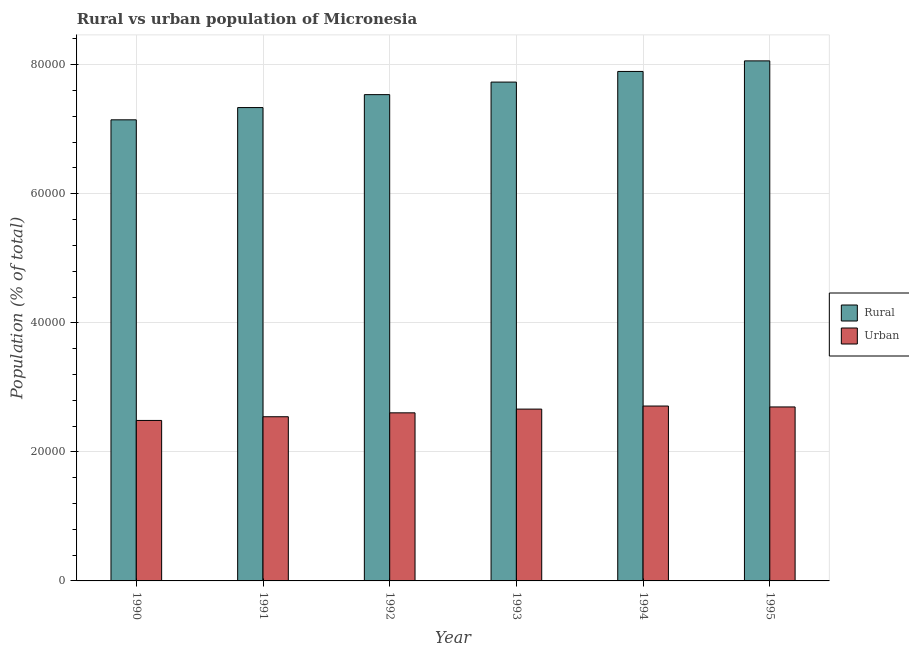How many different coloured bars are there?
Offer a very short reply. 2. Are the number of bars on each tick of the X-axis equal?
Provide a succinct answer. Yes. How many bars are there on the 2nd tick from the right?
Keep it short and to the point. 2. In how many cases, is the number of bars for a given year not equal to the number of legend labels?
Your answer should be compact. 0. What is the rural population density in 1993?
Your answer should be very brief. 7.73e+04. Across all years, what is the maximum urban population density?
Keep it short and to the point. 2.71e+04. Across all years, what is the minimum rural population density?
Ensure brevity in your answer.  7.15e+04. In which year was the urban population density maximum?
Keep it short and to the point. 1994. What is the total rural population density in the graph?
Provide a succinct answer. 4.57e+05. What is the difference between the rural population density in 1990 and that in 1993?
Your answer should be compact. -5848. What is the difference between the urban population density in 1991 and the rural population density in 1993?
Your answer should be very brief. -1186. What is the average rural population density per year?
Give a very brief answer. 7.62e+04. In the year 1990, what is the difference between the rural population density and urban population density?
Offer a terse response. 0. What is the ratio of the urban population density in 1991 to that in 1995?
Keep it short and to the point. 0.94. Is the difference between the urban population density in 1993 and 1994 greater than the difference between the rural population density in 1993 and 1994?
Your answer should be very brief. No. What is the difference between the highest and the second highest urban population density?
Ensure brevity in your answer.  140. What is the difference between the highest and the lowest rural population density?
Keep it short and to the point. 9134. In how many years, is the rural population density greater than the average rural population density taken over all years?
Your answer should be compact. 3. Is the sum of the rural population density in 1992 and 1993 greater than the maximum urban population density across all years?
Offer a terse response. Yes. What does the 1st bar from the left in 1993 represents?
Your answer should be very brief. Rural. What does the 2nd bar from the right in 1991 represents?
Ensure brevity in your answer.  Rural. What is the difference between two consecutive major ticks on the Y-axis?
Your answer should be compact. 2.00e+04. Are the values on the major ticks of Y-axis written in scientific E-notation?
Offer a very short reply. No. Does the graph contain any zero values?
Provide a succinct answer. No. How are the legend labels stacked?
Offer a terse response. Vertical. What is the title of the graph?
Your answer should be very brief. Rural vs urban population of Micronesia. Does "Diesel" appear as one of the legend labels in the graph?
Make the answer very short. No. What is the label or title of the X-axis?
Your answer should be very brief. Year. What is the label or title of the Y-axis?
Make the answer very short. Population (% of total). What is the Population (% of total) of Rural in 1990?
Provide a short and direct response. 7.15e+04. What is the Population (% of total) of Urban in 1990?
Ensure brevity in your answer.  2.49e+04. What is the Population (% of total) of Rural in 1991?
Your response must be concise. 7.34e+04. What is the Population (% of total) of Urban in 1991?
Provide a succinct answer. 2.54e+04. What is the Population (% of total) of Rural in 1992?
Your answer should be very brief. 7.54e+04. What is the Population (% of total) in Urban in 1992?
Offer a terse response. 2.60e+04. What is the Population (% of total) of Rural in 1993?
Provide a succinct answer. 7.73e+04. What is the Population (% of total) of Urban in 1993?
Offer a terse response. 2.66e+04. What is the Population (% of total) of Rural in 1994?
Your answer should be compact. 7.90e+04. What is the Population (% of total) in Urban in 1994?
Your answer should be compact. 2.71e+04. What is the Population (% of total) in Rural in 1995?
Keep it short and to the point. 8.06e+04. What is the Population (% of total) in Urban in 1995?
Offer a terse response. 2.70e+04. Across all years, what is the maximum Population (% of total) of Rural?
Provide a short and direct response. 8.06e+04. Across all years, what is the maximum Population (% of total) in Urban?
Ensure brevity in your answer.  2.71e+04. Across all years, what is the minimum Population (% of total) of Rural?
Make the answer very short. 7.15e+04. Across all years, what is the minimum Population (% of total) in Urban?
Provide a succinct answer. 2.49e+04. What is the total Population (% of total) of Rural in the graph?
Offer a very short reply. 4.57e+05. What is the total Population (% of total) in Urban in the graph?
Provide a succinct answer. 1.57e+05. What is the difference between the Population (% of total) of Rural in 1990 and that in 1991?
Offer a very short reply. -1897. What is the difference between the Population (% of total) in Urban in 1990 and that in 1991?
Make the answer very short. -572. What is the difference between the Population (% of total) of Rural in 1990 and that in 1992?
Provide a succinct answer. -3903. What is the difference between the Population (% of total) in Urban in 1990 and that in 1992?
Give a very brief answer. -1178. What is the difference between the Population (% of total) in Rural in 1990 and that in 1993?
Ensure brevity in your answer.  -5848. What is the difference between the Population (% of total) in Urban in 1990 and that in 1993?
Your answer should be very brief. -1758. What is the difference between the Population (% of total) of Rural in 1990 and that in 1994?
Provide a succinct answer. -7495. What is the difference between the Population (% of total) in Urban in 1990 and that in 1994?
Offer a very short reply. -2231. What is the difference between the Population (% of total) of Rural in 1990 and that in 1995?
Your answer should be very brief. -9134. What is the difference between the Population (% of total) in Urban in 1990 and that in 1995?
Ensure brevity in your answer.  -2091. What is the difference between the Population (% of total) of Rural in 1991 and that in 1992?
Offer a terse response. -2006. What is the difference between the Population (% of total) in Urban in 1991 and that in 1992?
Make the answer very short. -606. What is the difference between the Population (% of total) in Rural in 1991 and that in 1993?
Give a very brief answer. -3951. What is the difference between the Population (% of total) of Urban in 1991 and that in 1993?
Provide a succinct answer. -1186. What is the difference between the Population (% of total) of Rural in 1991 and that in 1994?
Your answer should be very brief. -5598. What is the difference between the Population (% of total) of Urban in 1991 and that in 1994?
Offer a very short reply. -1659. What is the difference between the Population (% of total) in Rural in 1991 and that in 1995?
Your answer should be very brief. -7237. What is the difference between the Population (% of total) of Urban in 1991 and that in 1995?
Ensure brevity in your answer.  -1519. What is the difference between the Population (% of total) in Rural in 1992 and that in 1993?
Give a very brief answer. -1945. What is the difference between the Population (% of total) of Urban in 1992 and that in 1993?
Provide a succinct answer. -580. What is the difference between the Population (% of total) in Rural in 1992 and that in 1994?
Provide a succinct answer. -3592. What is the difference between the Population (% of total) in Urban in 1992 and that in 1994?
Offer a very short reply. -1053. What is the difference between the Population (% of total) of Rural in 1992 and that in 1995?
Your answer should be compact. -5231. What is the difference between the Population (% of total) of Urban in 1992 and that in 1995?
Your answer should be compact. -913. What is the difference between the Population (% of total) in Rural in 1993 and that in 1994?
Ensure brevity in your answer.  -1647. What is the difference between the Population (% of total) in Urban in 1993 and that in 1994?
Give a very brief answer. -473. What is the difference between the Population (% of total) of Rural in 1993 and that in 1995?
Offer a very short reply. -3286. What is the difference between the Population (% of total) of Urban in 1993 and that in 1995?
Keep it short and to the point. -333. What is the difference between the Population (% of total) in Rural in 1994 and that in 1995?
Make the answer very short. -1639. What is the difference between the Population (% of total) of Urban in 1994 and that in 1995?
Offer a terse response. 140. What is the difference between the Population (% of total) in Rural in 1990 and the Population (% of total) in Urban in 1991?
Your answer should be very brief. 4.60e+04. What is the difference between the Population (% of total) in Rural in 1990 and the Population (% of total) in Urban in 1992?
Make the answer very short. 4.54e+04. What is the difference between the Population (% of total) of Rural in 1990 and the Population (% of total) of Urban in 1993?
Make the answer very short. 4.48e+04. What is the difference between the Population (% of total) in Rural in 1990 and the Population (% of total) in Urban in 1994?
Give a very brief answer. 4.44e+04. What is the difference between the Population (% of total) in Rural in 1990 and the Population (% of total) in Urban in 1995?
Your answer should be compact. 4.45e+04. What is the difference between the Population (% of total) of Rural in 1991 and the Population (% of total) of Urban in 1992?
Your response must be concise. 4.73e+04. What is the difference between the Population (% of total) of Rural in 1991 and the Population (% of total) of Urban in 1993?
Make the answer very short. 4.67e+04. What is the difference between the Population (% of total) in Rural in 1991 and the Population (% of total) in Urban in 1994?
Provide a short and direct response. 4.63e+04. What is the difference between the Population (% of total) of Rural in 1991 and the Population (% of total) of Urban in 1995?
Provide a succinct answer. 4.64e+04. What is the difference between the Population (% of total) in Rural in 1992 and the Population (% of total) in Urban in 1993?
Your answer should be very brief. 4.87e+04. What is the difference between the Population (% of total) in Rural in 1992 and the Population (% of total) in Urban in 1994?
Keep it short and to the point. 4.83e+04. What is the difference between the Population (% of total) of Rural in 1992 and the Population (% of total) of Urban in 1995?
Offer a terse response. 4.84e+04. What is the difference between the Population (% of total) in Rural in 1993 and the Population (% of total) in Urban in 1994?
Ensure brevity in your answer.  5.02e+04. What is the difference between the Population (% of total) in Rural in 1993 and the Population (% of total) in Urban in 1995?
Your answer should be compact. 5.03e+04. What is the difference between the Population (% of total) of Rural in 1994 and the Population (% of total) of Urban in 1995?
Provide a short and direct response. 5.20e+04. What is the average Population (% of total) of Rural per year?
Provide a succinct answer. 7.62e+04. What is the average Population (% of total) of Urban per year?
Your answer should be compact. 2.62e+04. In the year 1990, what is the difference between the Population (% of total) of Rural and Population (% of total) of Urban?
Offer a terse response. 4.66e+04. In the year 1991, what is the difference between the Population (% of total) of Rural and Population (% of total) of Urban?
Keep it short and to the point. 4.79e+04. In the year 1992, what is the difference between the Population (% of total) in Rural and Population (% of total) in Urban?
Ensure brevity in your answer.  4.93e+04. In the year 1993, what is the difference between the Population (% of total) in Rural and Population (% of total) in Urban?
Ensure brevity in your answer.  5.07e+04. In the year 1994, what is the difference between the Population (% of total) in Rural and Population (% of total) in Urban?
Your answer should be compact. 5.19e+04. In the year 1995, what is the difference between the Population (% of total) of Rural and Population (% of total) of Urban?
Your answer should be very brief. 5.36e+04. What is the ratio of the Population (% of total) of Rural in 1990 to that in 1991?
Provide a short and direct response. 0.97. What is the ratio of the Population (% of total) of Urban in 1990 to that in 1991?
Keep it short and to the point. 0.98. What is the ratio of the Population (% of total) of Rural in 1990 to that in 1992?
Ensure brevity in your answer.  0.95. What is the ratio of the Population (% of total) in Urban in 1990 to that in 1992?
Provide a short and direct response. 0.95. What is the ratio of the Population (% of total) in Rural in 1990 to that in 1993?
Ensure brevity in your answer.  0.92. What is the ratio of the Population (% of total) of Urban in 1990 to that in 1993?
Give a very brief answer. 0.93. What is the ratio of the Population (% of total) in Rural in 1990 to that in 1994?
Keep it short and to the point. 0.91. What is the ratio of the Population (% of total) in Urban in 1990 to that in 1994?
Keep it short and to the point. 0.92. What is the ratio of the Population (% of total) of Rural in 1990 to that in 1995?
Provide a short and direct response. 0.89. What is the ratio of the Population (% of total) in Urban in 1990 to that in 1995?
Your answer should be compact. 0.92. What is the ratio of the Population (% of total) of Rural in 1991 to that in 1992?
Your answer should be compact. 0.97. What is the ratio of the Population (% of total) in Urban in 1991 to that in 1992?
Provide a succinct answer. 0.98. What is the ratio of the Population (% of total) in Rural in 1991 to that in 1993?
Your response must be concise. 0.95. What is the ratio of the Population (% of total) in Urban in 1991 to that in 1993?
Your answer should be compact. 0.96. What is the ratio of the Population (% of total) of Rural in 1991 to that in 1994?
Your answer should be compact. 0.93. What is the ratio of the Population (% of total) of Urban in 1991 to that in 1994?
Keep it short and to the point. 0.94. What is the ratio of the Population (% of total) of Rural in 1991 to that in 1995?
Give a very brief answer. 0.91. What is the ratio of the Population (% of total) of Urban in 1991 to that in 1995?
Your answer should be very brief. 0.94. What is the ratio of the Population (% of total) in Rural in 1992 to that in 1993?
Offer a very short reply. 0.97. What is the ratio of the Population (% of total) in Urban in 1992 to that in 1993?
Provide a short and direct response. 0.98. What is the ratio of the Population (% of total) of Rural in 1992 to that in 1994?
Your answer should be compact. 0.95. What is the ratio of the Population (% of total) in Urban in 1992 to that in 1994?
Provide a succinct answer. 0.96. What is the ratio of the Population (% of total) in Rural in 1992 to that in 1995?
Keep it short and to the point. 0.94. What is the ratio of the Population (% of total) in Urban in 1992 to that in 1995?
Provide a succinct answer. 0.97. What is the ratio of the Population (% of total) of Rural in 1993 to that in 1994?
Your response must be concise. 0.98. What is the ratio of the Population (% of total) of Urban in 1993 to that in 1994?
Give a very brief answer. 0.98. What is the ratio of the Population (% of total) in Rural in 1993 to that in 1995?
Your answer should be compact. 0.96. What is the ratio of the Population (% of total) of Urban in 1993 to that in 1995?
Offer a terse response. 0.99. What is the ratio of the Population (% of total) in Rural in 1994 to that in 1995?
Offer a very short reply. 0.98. What is the ratio of the Population (% of total) of Urban in 1994 to that in 1995?
Ensure brevity in your answer.  1.01. What is the difference between the highest and the second highest Population (% of total) in Rural?
Your answer should be very brief. 1639. What is the difference between the highest and the second highest Population (% of total) of Urban?
Make the answer very short. 140. What is the difference between the highest and the lowest Population (% of total) of Rural?
Provide a succinct answer. 9134. What is the difference between the highest and the lowest Population (% of total) of Urban?
Your answer should be compact. 2231. 